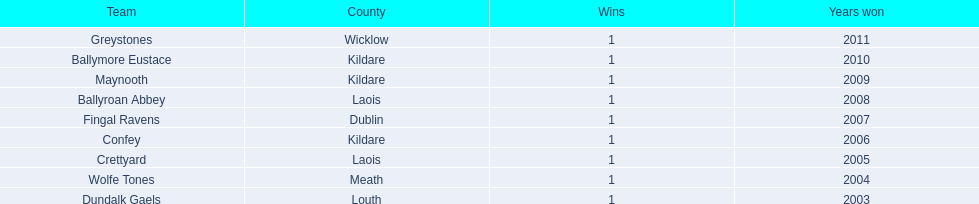In which place can ballymore eustace be found? Kildare. Apart from ballymore eustace, which teams are from kildare? Maynooth, Confey. In the 2009 contest between maynooth and confey, which team won? Maynooth. Could you parse the entire table? {'header': ['Team', 'County', 'Wins', 'Years won'], 'rows': [['Greystones', 'Wicklow', '1', '2011'], ['Ballymore Eustace', 'Kildare', '1', '2010'], ['Maynooth', 'Kildare', '1', '2009'], ['Ballyroan Abbey', 'Laois', '1', '2008'], ['Fingal Ravens', 'Dublin', '1', '2007'], ['Confey', 'Kildare', '1', '2006'], ['Crettyard', 'Laois', '1', '2005'], ['Wolfe Tones', 'Meath', '1', '2004'], ['Dundalk Gaels', 'Louth', '1', '2003']]} 